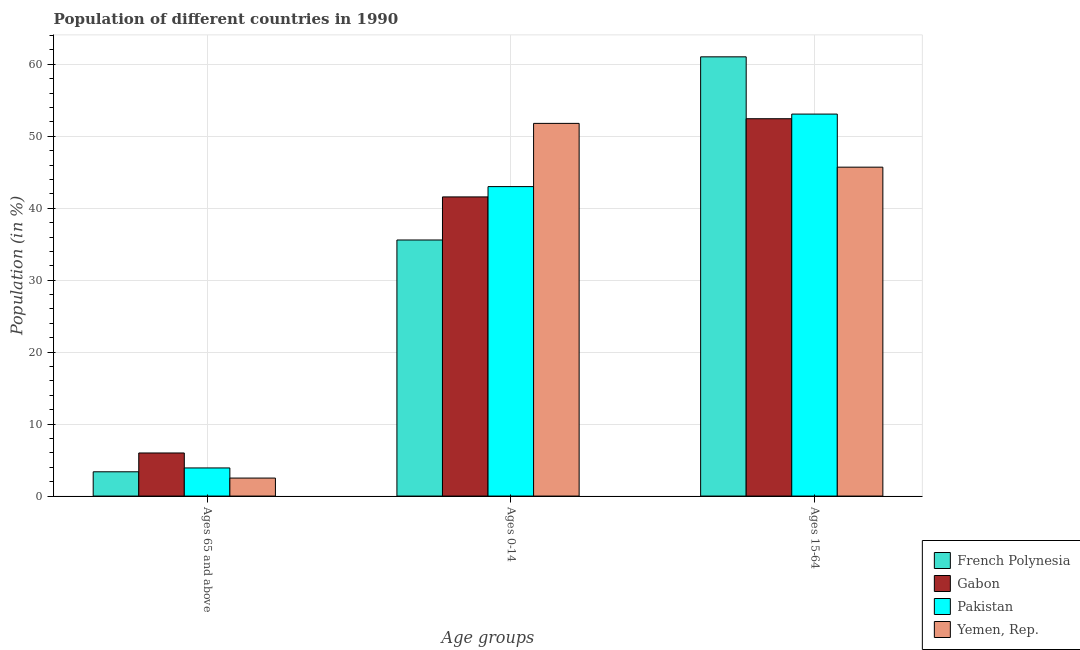Are the number of bars on each tick of the X-axis equal?
Your answer should be compact. Yes. How many bars are there on the 1st tick from the left?
Your answer should be compact. 4. How many bars are there on the 1st tick from the right?
Make the answer very short. 4. What is the label of the 1st group of bars from the left?
Keep it short and to the point. Ages 65 and above. What is the percentage of population within the age-group 0-14 in Yemen, Rep.?
Provide a succinct answer. 51.79. Across all countries, what is the maximum percentage of population within the age-group 0-14?
Your answer should be very brief. 51.79. Across all countries, what is the minimum percentage of population within the age-group 0-14?
Offer a terse response. 35.59. In which country was the percentage of population within the age-group 0-14 maximum?
Your answer should be compact. Yemen, Rep. In which country was the percentage of population within the age-group of 65 and above minimum?
Make the answer very short. Yemen, Rep. What is the total percentage of population within the age-group 15-64 in the graph?
Offer a terse response. 212.27. What is the difference between the percentage of population within the age-group of 65 and above in Yemen, Rep. and that in Gabon?
Your response must be concise. -3.49. What is the difference between the percentage of population within the age-group 15-64 in Gabon and the percentage of population within the age-group of 65 and above in French Polynesia?
Keep it short and to the point. 49.07. What is the average percentage of population within the age-group 15-64 per country?
Your response must be concise. 53.07. What is the difference between the percentage of population within the age-group 15-64 and percentage of population within the age-group 0-14 in Gabon?
Provide a short and direct response. 10.87. What is the ratio of the percentage of population within the age-group 0-14 in Pakistan to that in French Polynesia?
Offer a very short reply. 1.21. Is the percentage of population within the age-group of 65 and above in French Polynesia less than that in Pakistan?
Make the answer very short. Yes. Is the difference between the percentage of population within the age-group of 65 and above in Gabon and Pakistan greater than the difference between the percentage of population within the age-group 15-64 in Gabon and Pakistan?
Make the answer very short. Yes. What is the difference between the highest and the second highest percentage of population within the age-group 15-64?
Make the answer very short. 7.96. What is the difference between the highest and the lowest percentage of population within the age-group 0-14?
Make the answer very short. 16.2. Is the sum of the percentage of population within the age-group of 65 and above in French Polynesia and Yemen, Rep. greater than the maximum percentage of population within the age-group 15-64 across all countries?
Ensure brevity in your answer.  No. What does the 4th bar from the left in Ages 15-64 represents?
Provide a succinct answer. Yemen, Rep. What does the 4th bar from the right in Ages 65 and above represents?
Offer a very short reply. French Polynesia. How many bars are there?
Provide a succinct answer. 12. Are all the bars in the graph horizontal?
Keep it short and to the point. No. How many countries are there in the graph?
Offer a very short reply. 4. What is the difference between two consecutive major ticks on the Y-axis?
Offer a very short reply. 10. Are the values on the major ticks of Y-axis written in scientific E-notation?
Give a very brief answer. No. Does the graph contain grids?
Your response must be concise. Yes. How many legend labels are there?
Offer a very short reply. 4. How are the legend labels stacked?
Your response must be concise. Vertical. What is the title of the graph?
Ensure brevity in your answer.  Population of different countries in 1990. What is the label or title of the X-axis?
Offer a very short reply. Age groups. What is the label or title of the Y-axis?
Your answer should be very brief. Population (in %). What is the Population (in %) of French Polynesia in Ages 65 and above?
Keep it short and to the point. 3.37. What is the Population (in %) of Gabon in Ages 65 and above?
Give a very brief answer. 5.99. What is the Population (in %) in Pakistan in Ages 65 and above?
Make the answer very short. 3.91. What is the Population (in %) in Yemen, Rep. in Ages 65 and above?
Your answer should be very brief. 2.5. What is the Population (in %) of French Polynesia in Ages 0-14?
Provide a succinct answer. 35.59. What is the Population (in %) in Gabon in Ages 0-14?
Your response must be concise. 41.57. What is the Population (in %) in Pakistan in Ages 0-14?
Provide a succinct answer. 43.01. What is the Population (in %) of Yemen, Rep. in Ages 0-14?
Provide a succinct answer. 51.79. What is the Population (in %) in French Polynesia in Ages 15-64?
Your answer should be compact. 61.04. What is the Population (in %) in Gabon in Ages 15-64?
Keep it short and to the point. 52.44. What is the Population (in %) in Pakistan in Ages 15-64?
Keep it short and to the point. 53.08. What is the Population (in %) of Yemen, Rep. in Ages 15-64?
Your answer should be very brief. 45.71. Across all Age groups, what is the maximum Population (in %) of French Polynesia?
Make the answer very short. 61.04. Across all Age groups, what is the maximum Population (in %) of Gabon?
Your answer should be compact. 52.44. Across all Age groups, what is the maximum Population (in %) of Pakistan?
Provide a short and direct response. 53.08. Across all Age groups, what is the maximum Population (in %) of Yemen, Rep.?
Provide a short and direct response. 51.79. Across all Age groups, what is the minimum Population (in %) of French Polynesia?
Your answer should be compact. 3.37. Across all Age groups, what is the minimum Population (in %) in Gabon?
Your answer should be very brief. 5.99. Across all Age groups, what is the minimum Population (in %) in Pakistan?
Your answer should be compact. 3.91. Across all Age groups, what is the minimum Population (in %) in Yemen, Rep.?
Your answer should be compact. 2.5. What is the total Population (in %) of Gabon in the graph?
Ensure brevity in your answer.  100. What is the total Population (in %) of Pakistan in the graph?
Offer a terse response. 100. What is the total Population (in %) in Yemen, Rep. in the graph?
Make the answer very short. 100. What is the difference between the Population (in %) of French Polynesia in Ages 65 and above and that in Ages 0-14?
Your response must be concise. -32.21. What is the difference between the Population (in %) in Gabon in Ages 65 and above and that in Ages 0-14?
Offer a very short reply. -35.58. What is the difference between the Population (in %) in Pakistan in Ages 65 and above and that in Ages 0-14?
Give a very brief answer. -39.1. What is the difference between the Population (in %) of Yemen, Rep. in Ages 65 and above and that in Ages 0-14?
Keep it short and to the point. -49.29. What is the difference between the Population (in %) of French Polynesia in Ages 65 and above and that in Ages 15-64?
Your response must be concise. -57.67. What is the difference between the Population (in %) in Gabon in Ages 65 and above and that in Ages 15-64?
Your answer should be compact. -46.45. What is the difference between the Population (in %) in Pakistan in Ages 65 and above and that in Ages 15-64?
Make the answer very short. -49.18. What is the difference between the Population (in %) of Yemen, Rep. in Ages 65 and above and that in Ages 15-64?
Make the answer very short. -43.21. What is the difference between the Population (in %) in French Polynesia in Ages 0-14 and that in Ages 15-64?
Your answer should be very brief. -25.45. What is the difference between the Population (in %) of Gabon in Ages 0-14 and that in Ages 15-64?
Offer a terse response. -10.87. What is the difference between the Population (in %) of Pakistan in Ages 0-14 and that in Ages 15-64?
Your response must be concise. -10.08. What is the difference between the Population (in %) in Yemen, Rep. in Ages 0-14 and that in Ages 15-64?
Make the answer very short. 6.08. What is the difference between the Population (in %) of French Polynesia in Ages 65 and above and the Population (in %) of Gabon in Ages 0-14?
Keep it short and to the point. -38.2. What is the difference between the Population (in %) of French Polynesia in Ages 65 and above and the Population (in %) of Pakistan in Ages 0-14?
Make the answer very short. -39.63. What is the difference between the Population (in %) of French Polynesia in Ages 65 and above and the Population (in %) of Yemen, Rep. in Ages 0-14?
Your answer should be very brief. -48.42. What is the difference between the Population (in %) in Gabon in Ages 65 and above and the Population (in %) in Pakistan in Ages 0-14?
Your response must be concise. -37.02. What is the difference between the Population (in %) of Gabon in Ages 65 and above and the Population (in %) of Yemen, Rep. in Ages 0-14?
Ensure brevity in your answer.  -45.8. What is the difference between the Population (in %) of Pakistan in Ages 65 and above and the Population (in %) of Yemen, Rep. in Ages 0-14?
Keep it short and to the point. -47.88. What is the difference between the Population (in %) of French Polynesia in Ages 65 and above and the Population (in %) of Gabon in Ages 15-64?
Provide a succinct answer. -49.07. What is the difference between the Population (in %) of French Polynesia in Ages 65 and above and the Population (in %) of Pakistan in Ages 15-64?
Keep it short and to the point. -49.71. What is the difference between the Population (in %) in French Polynesia in Ages 65 and above and the Population (in %) in Yemen, Rep. in Ages 15-64?
Your response must be concise. -42.33. What is the difference between the Population (in %) of Gabon in Ages 65 and above and the Population (in %) of Pakistan in Ages 15-64?
Your answer should be very brief. -47.1. What is the difference between the Population (in %) of Gabon in Ages 65 and above and the Population (in %) of Yemen, Rep. in Ages 15-64?
Your response must be concise. -39.72. What is the difference between the Population (in %) of Pakistan in Ages 65 and above and the Population (in %) of Yemen, Rep. in Ages 15-64?
Make the answer very short. -41.8. What is the difference between the Population (in %) in French Polynesia in Ages 0-14 and the Population (in %) in Gabon in Ages 15-64?
Your answer should be compact. -16.85. What is the difference between the Population (in %) of French Polynesia in Ages 0-14 and the Population (in %) of Pakistan in Ages 15-64?
Offer a very short reply. -17.5. What is the difference between the Population (in %) in French Polynesia in Ages 0-14 and the Population (in %) in Yemen, Rep. in Ages 15-64?
Give a very brief answer. -10.12. What is the difference between the Population (in %) in Gabon in Ages 0-14 and the Population (in %) in Pakistan in Ages 15-64?
Your answer should be compact. -11.51. What is the difference between the Population (in %) of Gabon in Ages 0-14 and the Population (in %) of Yemen, Rep. in Ages 15-64?
Your answer should be very brief. -4.14. What is the difference between the Population (in %) of Pakistan in Ages 0-14 and the Population (in %) of Yemen, Rep. in Ages 15-64?
Your answer should be very brief. -2.7. What is the average Population (in %) in French Polynesia per Age groups?
Provide a short and direct response. 33.33. What is the average Population (in %) in Gabon per Age groups?
Provide a succinct answer. 33.33. What is the average Population (in %) of Pakistan per Age groups?
Your answer should be compact. 33.33. What is the average Population (in %) of Yemen, Rep. per Age groups?
Make the answer very short. 33.33. What is the difference between the Population (in %) of French Polynesia and Population (in %) of Gabon in Ages 65 and above?
Provide a succinct answer. -2.61. What is the difference between the Population (in %) of French Polynesia and Population (in %) of Pakistan in Ages 65 and above?
Your response must be concise. -0.53. What is the difference between the Population (in %) in French Polynesia and Population (in %) in Yemen, Rep. in Ages 65 and above?
Provide a short and direct response. 0.87. What is the difference between the Population (in %) of Gabon and Population (in %) of Pakistan in Ages 65 and above?
Your response must be concise. 2.08. What is the difference between the Population (in %) of Gabon and Population (in %) of Yemen, Rep. in Ages 65 and above?
Keep it short and to the point. 3.49. What is the difference between the Population (in %) in Pakistan and Population (in %) in Yemen, Rep. in Ages 65 and above?
Your answer should be very brief. 1.41. What is the difference between the Population (in %) of French Polynesia and Population (in %) of Gabon in Ages 0-14?
Your response must be concise. -5.99. What is the difference between the Population (in %) in French Polynesia and Population (in %) in Pakistan in Ages 0-14?
Ensure brevity in your answer.  -7.42. What is the difference between the Population (in %) of French Polynesia and Population (in %) of Yemen, Rep. in Ages 0-14?
Make the answer very short. -16.2. What is the difference between the Population (in %) in Gabon and Population (in %) in Pakistan in Ages 0-14?
Your answer should be very brief. -1.43. What is the difference between the Population (in %) in Gabon and Population (in %) in Yemen, Rep. in Ages 0-14?
Your response must be concise. -10.22. What is the difference between the Population (in %) of Pakistan and Population (in %) of Yemen, Rep. in Ages 0-14?
Offer a very short reply. -8.78. What is the difference between the Population (in %) of French Polynesia and Population (in %) of Gabon in Ages 15-64?
Provide a short and direct response. 8.6. What is the difference between the Population (in %) of French Polynesia and Population (in %) of Pakistan in Ages 15-64?
Provide a short and direct response. 7.96. What is the difference between the Population (in %) in French Polynesia and Population (in %) in Yemen, Rep. in Ages 15-64?
Keep it short and to the point. 15.33. What is the difference between the Population (in %) of Gabon and Population (in %) of Pakistan in Ages 15-64?
Your answer should be compact. -0.65. What is the difference between the Population (in %) in Gabon and Population (in %) in Yemen, Rep. in Ages 15-64?
Your answer should be very brief. 6.73. What is the difference between the Population (in %) of Pakistan and Population (in %) of Yemen, Rep. in Ages 15-64?
Your answer should be compact. 7.38. What is the ratio of the Population (in %) in French Polynesia in Ages 65 and above to that in Ages 0-14?
Provide a succinct answer. 0.09. What is the ratio of the Population (in %) in Gabon in Ages 65 and above to that in Ages 0-14?
Your response must be concise. 0.14. What is the ratio of the Population (in %) of Pakistan in Ages 65 and above to that in Ages 0-14?
Your answer should be very brief. 0.09. What is the ratio of the Population (in %) of Yemen, Rep. in Ages 65 and above to that in Ages 0-14?
Offer a very short reply. 0.05. What is the ratio of the Population (in %) of French Polynesia in Ages 65 and above to that in Ages 15-64?
Keep it short and to the point. 0.06. What is the ratio of the Population (in %) in Gabon in Ages 65 and above to that in Ages 15-64?
Provide a short and direct response. 0.11. What is the ratio of the Population (in %) in Pakistan in Ages 65 and above to that in Ages 15-64?
Make the answer very short. 0.07. What is the ratio of the Population (in %) in Yemen, Rep. in Ages 65 and above to that in Ages 15-64?
Keep it short and to the point. 0.05. What is the ratio of the Population (in %) in French Polynesia in Ages 0-14 to that in Ages 15-64?
Offer a terse response. 0.58. What is the ratio of the Population (in %) of Gabon in Ages 0-14 to that in Ages 15-64?
Your answer should be compact. 0.79. What is the ratio of the Population (in %) in Pakistan in Ages 0-14 to that in Ages 15-64?
Your answer should be very brief. 0.81. What is the ratio of the Population (in %) of Yemen, Rep. in Ages 0-14 to that in Ages 15-64?
Provide a short and direct response. 1.13. What is the difference between the highest and the second highest Population (in %) of French Polynesia?
Your response must be concise. 25.45. What is the difference between the highest and the second highest Population (in %) of Gabon?
Offer a very short reply. 10.87. What is the difference between the highest and the second highest Population (in %) in Pakistan?
Ensure brevity in your answer.  10.08. What is the difference between the highest and the second highest Population (in %) in Yemen, Rep.?
Make the answer very short. 6.08. What is the difference between the highest and the lowest Population (in %) in French Polynesia?
Your response must be concise. 57.67. What is the difference between the highest and the lowest Population (in %) in Gabon?
Offer a very short reply. 46.45. What is the difference between the highest and the lowest Population (in %) of Pakistan?
Your response must be concise. 49.18. What is the difference between the highest and the lowest Population (in %) in Yemen, Rep.?
Your answer should be very brief. 49.29. 